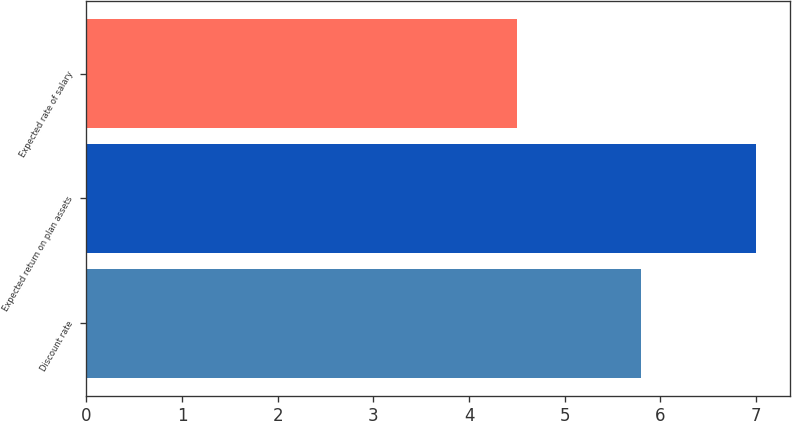Convert chart to OTSL. <chart><loc_0><loc_0><loc_500><loc_500><bar_chart><fcel>Discount rate<fcel>Expected return on plan assets<fcel>Expected rate of salary<nl><fcel>5.8<fcel>7<fcel>4.5<nl></chart> 